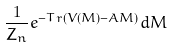Convert formula to latex. <formula><loc_0><loc_0><loc_500><loc_500>\frac { 1 } { Z _ { n } } e ^ { - T r ( V ( M ) - A M ) } d M</formula> 